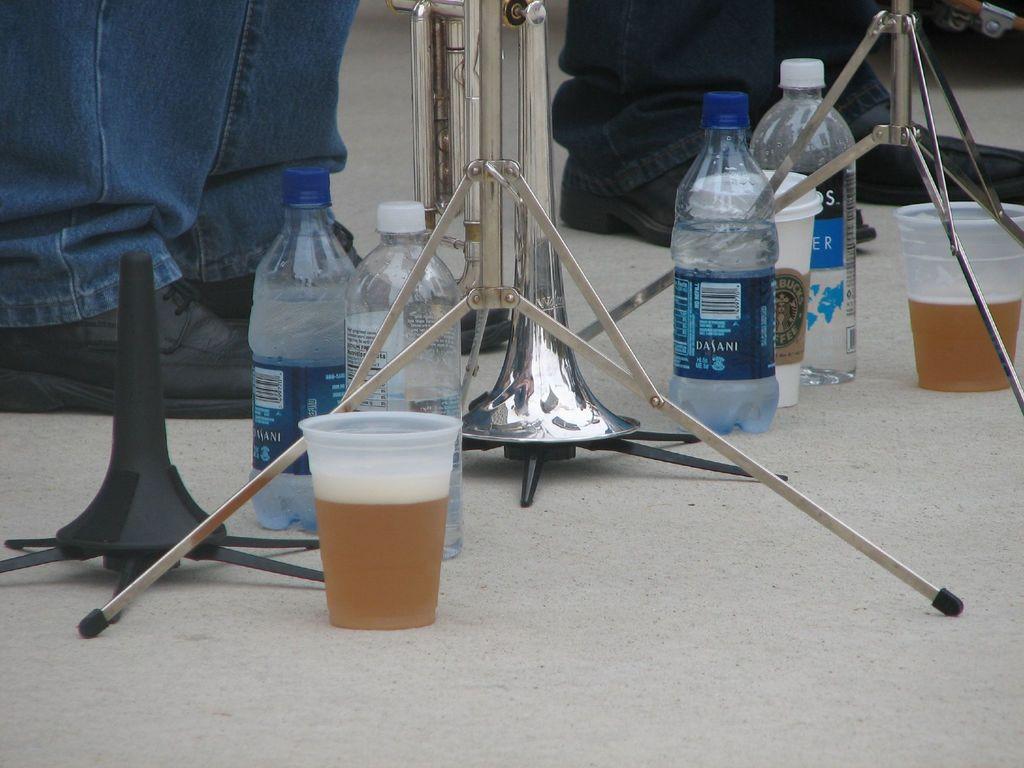What brand water is the bottle in the middle?
Give a very brief answer. Dasani. What kind of coffee cup is shown?
Your response must be concise. Starbucks. 